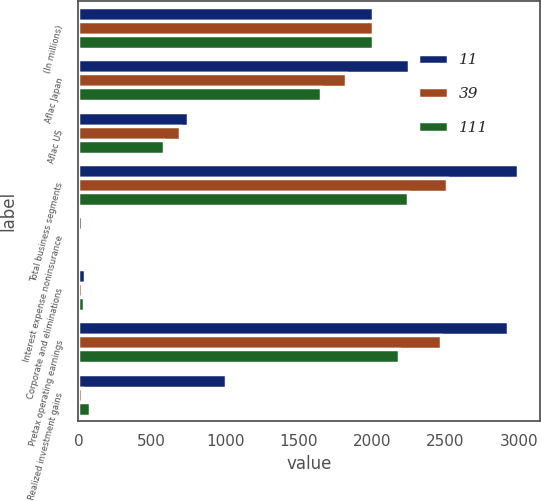<chart> <loc_0><loc_0><loc_500><loc_500><stacked_bar_chart><ecel><fcel>(In millions)<fcel>Aflac Japan<fcel>Aflac US<fcel>Total business segments<fcel>Interest expense noninsurance<fcel>Corporate and eliminations<fcel>Pretax operating earnings<fcel>Realized investment gains<nl><fcel>11<fcel>2008<fcel>2250<fcel>745<fcel>2994<fcel>26<fcel>42<fcel>2926<fcel>1007<nl><fcel>39<fcel>2007<fcel>1821<fcel>692<fcel>2513<fcel>21<fcel>25<fcel>2467<fcel>28<nl><fcel>111<fcel>2006<fcel>1652<fcel>585<fcel>2242<fcel>17<fcel>40<fcel>2185<fcel>79<nl></chart> 